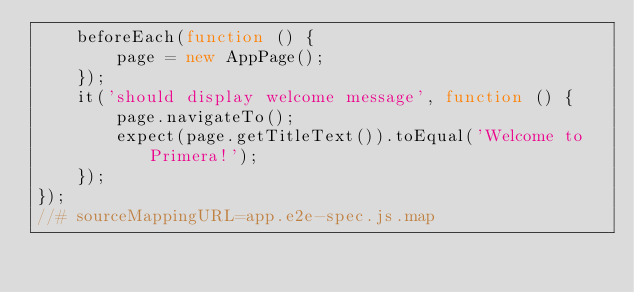Convert code to text. <code><loc_0><loc_0><loc_500><loc_500><_JavaScript_>    beforeEach(function () {
        page = new AppPage();
    });
    it('should display welcome message', function () {
        page.navigateTo();
        expect(page.getTitleText()).toEqual('Welcome to Primera!');
    });
});
//# sourceMappingURL=app.e2e-spec.js.map</code> 